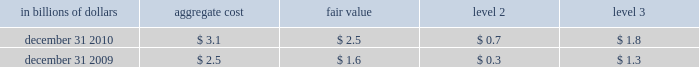The significant changes from december 31 , 2008 to december 31 , 2009 in level 3 assets and liabilities are due to : a net decrease in trading securities of $ 10.8 billion that was driven by : 2022 net transfers of $ 6.5 billion , due mainly to the transfer of debt 2013 securities from level 3 to level 2 due to increased liquidity and pricing transparency ; and net settlements of $ 5.8 billion , due primarily to the liquidations of 2013 subprime securities of $ 4.1 billion .
The change in net trading derivatives driven by : 2022 a net loss of $ 4.9 billion relating to complex derivative contracts , 2013 such as those linked to credit , equity and commodity exposures .
These losses include both realized and unrealized losses during 2009 and are partially offset by gains recognized in instruments that have been classified in levels 1 and 2 ; and net increase in derivative assets of $ 4.3 billion , which includes cash 2013 settlements of derivative contracts in an unrealized loss position , notably those linked to subprime exposures .
The decrease in level 3 investments of $ 6.9 billion primarily 2022 resulted from : a reduction of $ 5.0 billion , due mainly to paydowns on debt 2013 securities and sales of private equity investments ; the net transfer of investment securities from level 3 to level 2 2013 of $ 1.5 billion , due to increased availability of observable pricing inputs ; and net losses recognized of $ 0.4 billion due mainly to losses on non- 2013 marketable equity securities including write-downs on private equity investments .
The decrease in securities sold under agreements to repurchase of 2022 $ 9.1 billion is driven by a $ 8.6 billion net transfers from level 3 to level 2 as effective maturity dates on structured repos have shortened .
The decrease in long-term debt of $ 1.5 billion is driven mainly by 2022 $ 1.3 billion of net terminations of structured notes .
Transfers between level 1 and level 2 of the fair value hierarchy the company did not have any significant transfers of assets or liabilities between levels 1 and 2 of the fair value hierarchy during 2010 .
Items measured at fair value on a nonrecurring basis certain assets and liabilities are measured at fair value on a nonrecurring basis and therefore are not included in the tables above .
These include assets measured at cost that have been written down to fair value during the periods as a result of an impairment .
In addition , these assets include loans held-for-sale that are measured at locom that were recognized at fair value below cost at the end of the period .
The fair value of loans measured on a locom basis is determined where possible using quoted secondary-market prices .
Such loans are generally classified as level 2 of the fair value hierarchy given the level of activity in the market and the frequency of available quotes .
If no such quoted price exists , the fair value of a loan is determined using quoted prices for a similar asset or assets , adjusted for the specific attributes of that loan .
The table presents all loans held-for-sale that are carried at locom as of december 31 , 2010 and 2009 : in billions of dollars aggregate cost fair value level 2 level 3 .

What is the difference in billions of all loans held-for-sale that are carried at locom level 3 between 2009 and 2010? 
Computations: (1.8 - 1.3)
Answer: 0.5. 